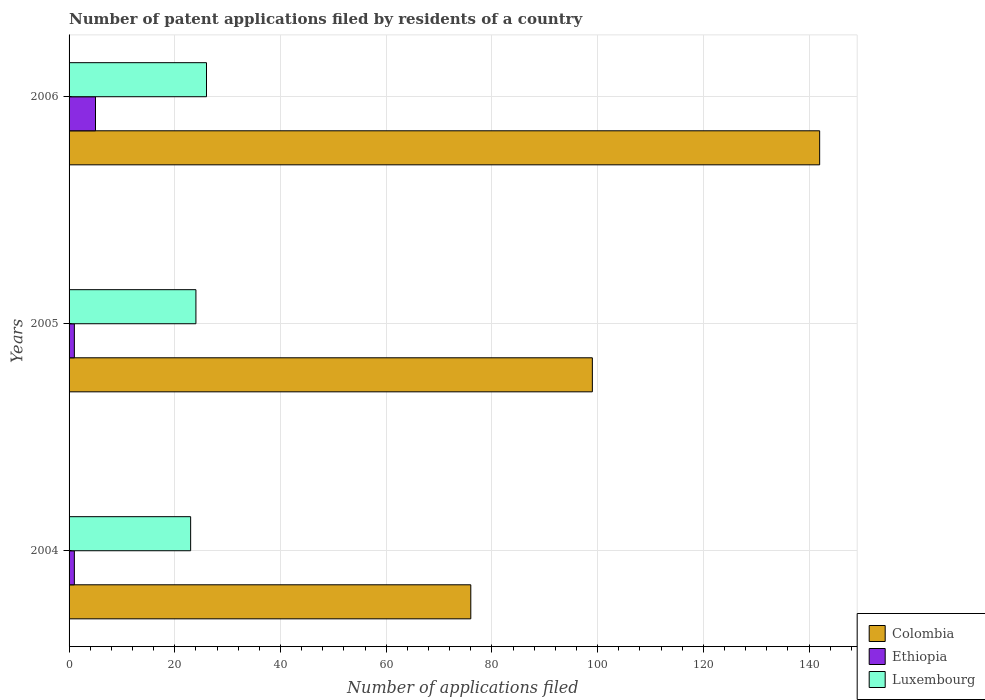How many different coloured bars are there?
Your answer should be compact. 3. Are the number of bars per tick equal to the number of legend labels?
Give a very brief answer. Yes. How many bars are there on the 2nd tick from the top?
Make the answer very short. 3. In how many cases, is the number of bars for a given year not equal to the number of legend labels?
Ensure brevity in your answer.  0. Across all years, what is the maximum number of applications filed in Colombia?
Your answer should be compact. 142. What is the difference between the number of applications filed in Ethiopia in 2004 and that in 2006?
Offer a very short reply. -4. What is the difference between the number of applications filed in Ethiopia in 2004 and the number of applications filed in Colombia in 2005?
Your answer should be compact. -98. What is the average number of applications filed in Colombia per year?
Offer a terse response. 105.67. In the year 2004, what is the difference between the number of applications filed in Luxembourg and number of applications filed in Ethiopia?
Your response must be concise. 22. In how many years, is the number of applications filed in Luxembourg greater than 56 ?
Provide a succinct answer. 0. What is the ratio of the number of applications filed in Luxembourg in 2004 to that in 2005?
Keep it short and to the point. 0.96. Is the difference between the number of applications filed in Luxembourg in 2004 and 2006 greater than the difference between the number of applications filed in Ethiopia in 2004 and 2006?
Give a very brief answer. Yes. What is the difference between the highest and the second highest number of applications filed in Colombia?
Your response must be concise. 43. What is the difference between the highest and the lowest number of applications filed in Ethiopia?
Offer a terse response. 4. In how many years, is the number of applications filed in Colombia greater than the average number of applications filed in Colombia taken over all years?
Provide a short and direct response. 1. Is the sum of the number of applications filed in Colombia in 2004 and 2005 greater than the maximum number of applications filed in Ethiopia across all years?
Keep it short and to the point. Yes. What does the 1st bar from the bottom in 2005 represents?
Your response must be concise. Colombia. Are all the bars in the graph horizontal?
Give a very brief answer. Yes. How many years are there in the graph?
Offer a very short reply. 3. What is the difference between two consecutive major ticks on the X-axis?
Provide a short and direct response. 20. Are the values on the major ticks of X-axis written in scientific E-notation?
Make the answer very short. No. Does the graph contain any zero values?
Provide a succinct answer. No. Does the graph contain grids?
Offer a very short reply. Yes. Where does the legend appear in the graph?
Offer a very short reply. Bottom right. How many legend labels are there?
Provide a succinct answer. 3. How are the legend labels stacked?
Your response must be concise. Vertical. What is the title of the graph?
Your answer should be compact. Number of patent applications filed by residents of a country. What is the label or title of the X-axis?
Provide a succinct answer. Number of applications filed. What is the Number of applications filed of Colombia in 2004?
Keep it short and to the point. 76. What is the Number of applications filed in Ethiopia in 2004?
Give a very brief answer. 1. What is the Number of applications filed of Luxembourg in 2004?
Provide a short and direct response. 23. What is the Number of applications filed in Luxembourg in 2005?
Offer a terse response. 24. What is the Number of applications filed of Colombia in 2006?
Your answer should be compact. 142. What is the Number of applications filed of Ethiopia in 2006?
Offer a very short reply. 5. Across all years, what is the maximum Number of applications filed in Colombia?
Provide a short and direct response. 142. Across all years, what is the maximum Number of applications filed in Luxembourg?
Keep it short and to the point. 26. Across all years, what is the minimum Number of applications filed in Luxembourg?
Ensure brevity in your answer.  23. What is the total Number of applications filed of Colombia in the graph?
Offer a very short reply. 317. What is the difference between the Number of applications filed in Luxembourg in 2004 and that in 2005?
Provide a short and direct response. -1. What is the difference between the Number of applications filed of Colombia in 2004 and that in 2006?
Provide a succinct answer. -66. What is the difference between the Number of applications filed of Ethiopia in 2004 and that in 2006?
Your response must be concise. -4. What is the difference between the Number of applications filed of Colombia in 2005 and that in 2006?
Your response must be concise. -43. What is the difference between the Number of applications filed in Ethiopia in 2005 and that in 2006?
Give a very brief answer. -4. What is the difference between the Number of applications filed of Colombia in 2004 and the Number of applications filed of Ethiopia in 2005?
Offer a very short reply. 75. What is the difference between the Number of applications filed of Colombia in 2004 and the Number of applications filed of Luxembourg in 2005?
Your answer should be compact. 52. What is the difference between the Number of applications filed of Ethiopia in 2004 and the Number of applications filed of Luxembourg in 2005?
Provide a short and direct response. -23. What is the difference between the Number of applications filed of Colombia in 2004 and the Number of applications filed of Ethiopia in 2006?
Your answer should be very brief. 71. What is the difference between the Number of applications filed of Ethiopia in 2004 and the Number of applications filed of Luxembourg in 2006?
Keep it short and to the point. -25. What is the difference between the Number of applications filed of Colombia in 2005 and the Number of applications filed of Ethiopia in 2006?
Give a very brief answer. 94. What is the difference between the Number of applications filed in Ethiopia in 2005 and the Number of applications filed in Luxembourg in 2006?
Provide a short and direct response. -25. What is the average Number of applications filed of Colombia per year?
Provide a succinct answer. 105.67. What is the average Number of applications filed of Ethiopia per year?
Your answer should be very brief. 2.33. What is the average Number of applications filed of Luxembourg per year?
Your answer should be very brief. 24.33. In the year 2004, what is the difference between the Number of applications filed in Colombia and Number of applications filed in Ethiopia?
Offer a very short reply. 75. In the year 2004, what is the difference between the Number of applications filed in Colombia and Number of applications filed in Luxembourg?
Your response must be concise. 53. In the year 2004, what is the difference between the Number of applications filed in Ethiopia and Number of applications filed in Luxembourg?
Provide a short and direct response. -22. In the year 2006, what is the difference between the Number of applications filed of Colombia and Number of applications filed of Ethiopia?
Your answer should be compact. 137. In the year 2006, what is the difference between the Number of applications filed in Colombia and Number of applications filed in Luxembourg?
Your answer should be compact. 116. What is the ratio of the Number of applications filed in Colombia in 2004 to that in 2005?
Your answer should be very brief. 0.77. What is the ratio of the Number of applications filed of Colombia in 2004 to that in 2006?
Keep it short and to the point. 0.54. What is the ratio of the Number of applications filed in Ethiopia in 2004 to that in 2006?
Give a very brief answer. 0.2. What is the ratio of the Number of applications filed in Luxembourg in 2004 to that in 2006?
Give a very brief answer. 0.88. What is the ratio of the Number of applications filed in Colombia in 2005 to that in 2006?
Keep it short and to the point. 0.7. What is the ratio of the Number of applications filed in Ethiopia in 2005 to that in 2006?
Your answer should be very brief. 0.2. What is the ratio of the Number of applications filed of Luxembourg in 2005 to that in 2006?
Give a very brief answer. 0.92. What is the difference between the highest and the second highest Number of applications filed of Ethiopia?
Keep it short and to the point. 4. What is the difference between the highest and the second highest Number of applications filed in Luxembourg?
Your answer should be very brief. 2. What is the difference between the highest and the lowest Number of applications filed of Colombia?
Ensure brevity in your answer.  66. What is the difference between the highest and the lowest Number of applications filed of Ethiopia?
Ensure brevity in your answer.  4. 